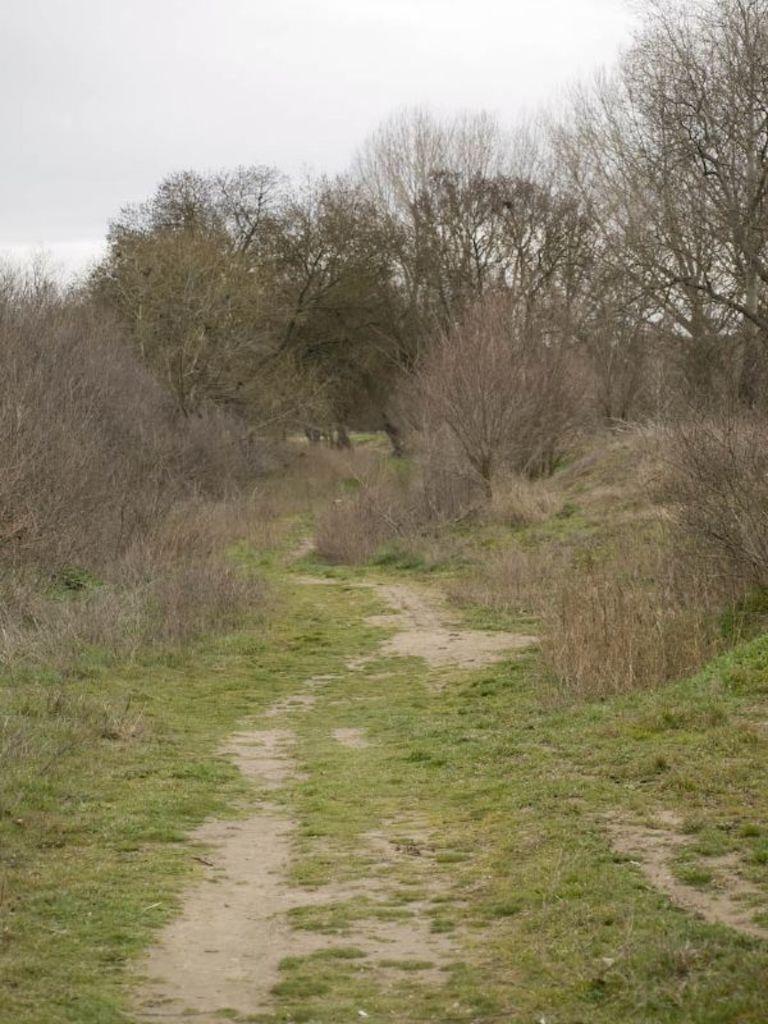Please provide a concise description of this image. In this picture I can see the grass in front and in the middle of this picture I can see the plants and trees. In the background I can see the sky. 